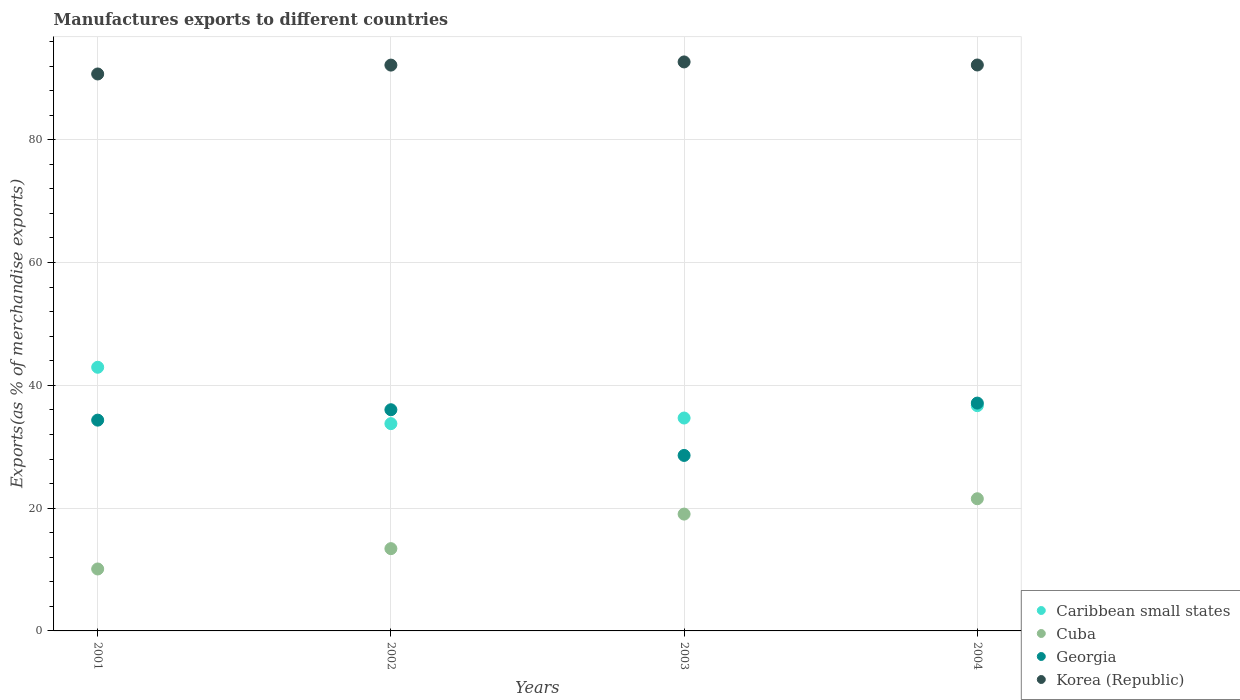How many different coloured dotlines are there?
Make the answer very short. 4. What is the percentage of exports to different countries in Korea (Republic) in 2001?
Your answer should be compact. 90.71. Across all years, what is the maximum percentage of exports to different countries in Cuba?
Your answer should be compact. 21.53. Across all years, what is the minimum percentage of exports to different countries in Korea (Republic)?
Your response must be concise. 90.71. In which year was the percentage of exports to different countries in Korea (Republic) maximum?
Give a very brief answer. 2003. What is the total percentage of exports to different countries in Caribbean small states in the graph?
Keep it short and to the point. 148.07. What is the difference between the percentage of exports to different countries in Korea (Republic) in 2001 and that in 2004?
Provide a short and direct response. -1.46. What is the difference between the percentage of exports to different countries in Cuba in 2002 and the percentage of exports to different countries in Caribbean small states in 2001?
Your answer should be compact. -29.54. What is the average percentage of exports to different countries in Korea (Republic) per year?
Keep it short and to the point. 91.93. In the year 2003, what is the difference between the percentage of exports to different countries in Georgia and percentage of exports to different countries in Cuba?
Your response must be concise. 9.56. What is the ratio of the percentage of exports to different countries in Georgia in 2003 to that in 2004?
Keep it short and to the point. 0.77. Is the percentage of exports to different countries in Korea (Republic) in 2003 less than that in 2004?
Make the answer very short. No. Is the difference between the percentage of exports to different countries in Georgia in 2002 and 2003 greater than the difference between the percentage of exports to different countries in Cuba in 2002 and 2003?
Offer a very short reply. Yes. What is the difference between the highest and the second highest percentage of exports to different countries in Caribbean small states?
Make the answer very short. 6.26. What is the difference between the highest and the lowest percentage of exports to different countries in Georgia?
Your response must be concise. 8.53. In how many years, is the percentage of exports to different countries in Georgia greater than the average percentage of exports to different countries in Georgia taken over all years?
Make the answer very short. 3. Is it the case that in every year, the sum of the percentage of exports to different countries in Georgia and percentage of exports to different countries in Cuba  is greater than the percentage of exports to different countries in Korea (Republic)?
Offer a terse response. No. What is the difference between two consecutive major ticks on the Y-axis?
Offer a terse response. 20. Are the values on the major ticks of Y-axis written in scientific E-notation?
Give a very brief answer. No. Does the graph contain any zero values?
Make the answer very short. No. What is the title of the graph?
Your response must be concise. Manufactures exports to different countries. What is the label or title of the Y-axis?
Your response must be concise. Exports(as % of merchandise exports). What is the Exports(as % of merchandise exports) of Caribbean small states in 2001?
Ensure brevity in your answer.  42.94. What is the Exports(as % of merchandise exports) of Cuba in 2001?
Keep it short and to the point. 10.09. What is the Exports(as % of merchandise exports) in Georgia in 2001?
Keep it short and to the point. 34.33. What is the Exports(as % of merchandise exports) of Korea (Republic) in 2001?
Your answer should be very brief. 90.71. What is the Exports(as % of merchandise exports) in Caribbean small states in 2002?
Offer a very short reply. 33.76. What is the Exports(as % of merchandise exports) in Cuba in 2002?
Make the answer very short. 13.4. What is the Exports(as % of merchandise exports) of Georgia in 2002?
Make the answer very short. 36.03. What is the Exports(as % of merchandise exports) of Korea (Republic) in 2002?
Offer a very short reply. 92.16. What is the Exports(as % of merchandise exports) in Caribbean small states in 2003?
Your response must be concise. 34.68. What is the Exports(as % of merchandise exports) of Cuba in 2003?
Offer a very short reply. 19.03. What is the Exports(as % of merchandise exports) of Georgia in 2003?
Offer a terse response. 28.58. What is the Exports(as % of merchandise exports) of Korea (Republic) in 2003?
Make the answer very short. 92.68. What is the Exports(as % of merchandise exports) of Caribbean small states in 2004?
Make the answer very short. 36.69. What is the Exports(as % of merchandise exports) in Cuba in 2004?
Offer a terse response. 21.53. What is the Exports(as % of merchandise exports) of Georgia in 2004?
Ensure brevity in your answer.  37.11. What is the Exports(as % of merchandise exports) in Korea (Republic) in 2004?
Provide a succinct answer. 92.18. Across all years, what is the maximum Exports(as % of merchandise exports) in Caribbean small states?
Your response must be concise. 42.94. Across all years, what is the maximum Exports(as % of merchandise exports) in Cuba?
Offer a terse response. 21.53. Across all years, what is the maximum Exports(as % of merchandise exports) in Georgia?
Make the answer very short. 37.11. Across all years, what is the maximum Exports(as % of merchandise exports) of Korea (Republic)?
Make the answer very short. 92.68. Across all years, what is the minimum Exports(as % of merchandise exports) in Caribbean small states?
Your answer should be very brief. 33.76. Across all years, what is the minimum Exports(as % of merchandise exports) in Cuba?
Make the answer very short. 10.09. Across all years, what is the minimum Exports(as % of merchandise exports) of Georgia?
Ensure brevity in your answer.  28.58. Across all years, what is the minimum Exports(as % of merchandise exports) in Korea (Republic)?
Your answer should be very brief. 90.71. What is the total Exports(as % of merchandise exports) of Caribbean small states in the graph?
Ensure brevity in your answer.  148.07. What is the total Exports(as % of merchandise exports) in Cuba in the graph?
Provide a succinct answer. 64.05. What is the total Exports(as % of merchandise exports) in Georgia in the graph?
Give a very brief answer. 136.05. What is the total Exports(as % of merchandise exports) in Korea (Republic) in the graph?
Your answer should be compact. 367.73. What is the difference between the Exports(as % of merchandise exports) of Caribbean small states in 2001 and that in 2002?
Your answer should be compact. 9.18. What is the difference between the Exports(as % of merchandise exports) of Cuba in 2001 and that in 2002?
Keep it short and to the point. -3.31. What is the difference between the Exports(as % of merchandise exports) of Georgia in 2001 and that in 2002?
Provide a short and direct response. -1.69. What is the difference between the Exports(as % of merchandise exports) in Korea (Republic) in 2001 and that in 2002?
Your response must be concise. -1.45. What is the difference between the Exports(as % of merchandise exports) in Caribbean small states in 2001 and that in 2003?
Your answer should be compact. 8.27. What is the difference between the Exports(as % of merchandise exports) of Cuba in 2001 and that in 2003?
Offer a terse response. -8.94. What is the difference between the Exports(as % of merchandise exports) in Georgia in 2001 and that in 2003?
Keep it short and to the point. 5.75. What is the difference between the Exports(as % of merchandise exports) of Korea (Republic) in 2001 and that in 2003?
Provide a short and direct response. -1.96. What is the difference between the Exports(as % of merchandise exports) in Caribbean small states in 2001 and that in 2004?
Make the answer very short. 6.26. What is the difference between the Exports(as % of merchandise exports) of Cuba in 2001 and that in 2004?
Your answer should be very brief. -11.44. What is the difference between the Exports(as % of merchandise exports) of Georgia in 2001 and that in 2004?
Ensure brevity in your answer.  -2.78. What is the difference between the Exports(as % of merchandise exports) in Korea (Republic) in 2001 and that in 2004?
Keep it short and to the point. -1.46. What is the difference between the Exports(as % of merchandise exports) of Caribbean small states in 2002 and that in 2003?
Your response must be concise. -0.92. What is the difference between the Exports(as % of merchandise exports) in Cuba in 2002 and that in 2003?
Your answer should be very brief. -5.63. What is the difference between the Exports(as % of merchandise exports) of Georgia in 2002 and that in 2003?
Give a very brief answer. 7.44. What is the difference between the Exports(as % of merchandise exports) of Korea (Republic) in 2002 and that in 2003?
Your answer should be very brief. -0.52. What is the difference between the Exports(as % of merchandise exports) of Caribbean small states in 2002 and that in 2004?
Offer a very short reply. -2.93. What is the difference between the Exports(as % of merchandise exports) of Cuba in 2002 and that in 2004?
Your answer should be very brief. -8.13. What is the difference between the Exports(as % of merchandise exports) of Georgia in 2002 and that in 2004?
Offer a terse response. -1.08. What is the difference between the Exports(as % of merchandise exports) in Korea (Republic) in 2002 and that in 2004?
Offer a terse response. -0.02. What is the difference between the Exports(as % of merchandise exports) of Caribbean small states in 2003 and that in 2004?
Your answer should be very brief. -2.01. What is the difference between the Exports(as % of merchandise exports) of Cuba in 2003 and that in 2004?
Your response must be concise. -2.5. What is the difference between the Exports(as % of merchandise exports) of Georgia in 2003 and that in 2004?
Your response must be concise. -8.53. What is the difference between the Exports(as % of merchandise exports) in Korea (Republic) in 2003 and that in 2004?
Provide a short and direct response. 0.5. What is the difference between the Exports(as % of merchandise exports) of Caribbean small states in 2001 and the Exports(as % of merchandise exports) of Cuba in 2002?
Your answer should be compact. 29.54. What is the difference between the Exports(as % of merchandise exports) in Caribbean small states in 2001 and the Exports(as % of merchandise exports) in Georgia in 2002?
Your response must be concise. 6.92. What is the difference between the Exports(as % of merchandise exports) in Caribbean small states in 2001 and the Exports(as % of merchandise exports) in Korea (Republic) in 2002?
Provide a succinct answer. -49.22. What is the difference between the Exports(as % of merchandise exports) in Cuba in 2001 and the Exports(as % of merchandise exports) in Georgia in 2002?
Your response must be concise. -25.94. What is the difference between the Exports(as % of merchandise exports) of Cuba in 2001 and the Exports(as % of merchandise exports) of Korea (Republic) in 2002?
Your answer should be very brief. -82.07. What is the difference between the Exports(as % of merchandise exports) of Georgia in 2001 and the Exports(as % of merchandise exports) of Korea (Republic) in 2002?
Your answer should be compact. -57.83. What is the difference between the Exports(as % of merchandise exports) in Caribbean small states in 2001 and the Exports(as % of merchandise exports) in Cuba in 2003?
Provide a succinct answer. 23.92. What is the difference between the Exports(as % of merchandise exports) in Caribbean small states in 2001 and the Exports(as % of merchandise exports) in Georgia in 2003?
Your answer should be very brief. 14.36. What is the difference between the Exports(as % of merchandise exports) of Caribbean small states in 2001 and the Exports(as % of merchandise exports) of Korea (Republic) in 2003?
Keep it short and to the point. -49.73. What is the difference between the Exports(as % of merchandise exports) of Cuba in 2001 and the Exports(as % of merchandise exports) of Georgia in 2003?
Give a very brief answer. -18.49. What is the difference between the Exports(as % of merchandise exports) of Cuba in 2001 and the Exports(as % of merchandise exports) of Korea (Republic) in 2003?
Provide a short and direct response. -82.59. What is the difference between the Exports(as % of merchandise exports) of Georgia in 2001 and the Exports(as % of merchandise exports) of Korea (Republic) in 2003?
Offer a very short reply. -58.34. What is the difference between the Exports(as % of merchandise exports) of Caribbean small states in 2001 and the Exports(as % of merchandise exports) of Cuba in 2004?
Offer a terse response. 21.42. What is the difference between the Exports(as % of merchandise exports) of Caribbean small states in 2001 and the Exports(as % of merchandise exports) of Georgia in 2004?
Offer a very short reply. 5.83. What is the difference between the Exports(as % of merchandise exports) in Caribbean small states in 2001 and the Exports(as % of merchandise exports) in Korea (Republic) in 2004?
Your response must be concise. -49.23. What is the difference between the Exports(as % of merchandise exports) in Cuba in 2001 and the Exports(as % of merchandise exports) in Georgia in 2004?
Ensure brevity in your answer.  -27.02. What is the difference between the Exports(as % of merchandise exports) of Cuba in 2001 and the Exports(as % of merchandise exports) of Korea (Republic) in 2004?
Provide a short and direct response. -82.09. What is the difference between the Exports(as % of merchandise exports) of Georgia in 2001 and the Exports(as % of merchandise exports) of Korea (Republic) in 2004?
Ensure brevity in your answer.  -57.85. What is the difference between the Exports(as % of merchandise exports) in Caribbean small states in 2002 and the Exports(as % of merchandise exports) in Cuba in 2003?
Your answer should be very brief. 14.73. What is the difference between the Exports(as % of merchandise exports) in Caribbean small states in 2002 and the Exports(as % of merchandise exports) in Georgia in 2003?
Ensure brevity in your answer.  5.18. What is the difference between the Exports(as % of merchandise exports) in Caribbean small states in 2002 and the Exports(as % of merchandise exports) in Korea (Republic) in 2003?
Your answer should be very brief. -58.92. What is the difference between the Exports(as % of merchandise exports) in Cuba in 2002 and the Exports(as % of merchandise exports) in Georgia in 2003?
Your answer should be compact. -15.18. What is the difference between the Exports(as % of merchandise exports) of Cuba in 2002 and the Exports(as % of merchandise exports) of Korea (Republic) in 2003?
Offer a terse response. -79.28. What is the difference between the Exports(as % of merchandise exports) in Georgia in 2002 and the Exports(as % of merchandise exports) in Korea (Republic) in 2003?
Offer a very short reply. -56.65. What is the difference between the Exports(as % of merchandise exports) of Caribbean small states in 2002 and the Exports(as % of merchandise exports) of Cuba in 2004?
Provide a short and direct response. 12.23. What is the difference between the Exports(as % of merchandise exports) of Caribbean small states in 2002 and the Exports(as % of merchandise exports) of Georgia in 2004?
Offer a very short reply. -3.35. What is the difference between the Exports(as % of merchandise exports) in Caribbean small states in 2002 and the Exports(as % of merchandise exports) in Korea (Republic) in 2004?
Offer a very short reply. -58.42. What is the difference between the Exports(as % of merchandise exports) in Cuba in 2002 and the Exports(as % of merchandise exports) in Georgia in 2004?
Give a very brief answer. -23.71. What is the difference between the Exports(as % of merchandise exports) of Cuba in 2002 and the Exports(as % of merchandise exports) of Korea (Republic) in 2004?
Your response must be concise. -78.78. What is the difference between the Exports(as % of merchandise exports) in Georgia in 2002 and the Exports(as % of merchandise exports) in Korea (Republic) in 2004?
Your answer should be compact. -56.15. What is the difference between the Exports(as % of merchandise exports) of Caribbean small states in 2003 and the Exports(as % of merchandise exports) of Cuba in 2004?
Offer a terse response. 13.15. What is the difference between the Exports(as % of merchandise exports) of Caribbean small states in 2003 and the Exports(as % of merchandise exports) of Georgia in 2004?
Keep it short and to the point. -2.43. What is the difference between the Exports(as % of merchandise exports) in Caribbean small states in 2003 and the Exports(as % of merchandise exports) in Korea (Republic) in 2004?
Give a very brief answer. -57.5. What is the difference between the Exports(as % of merchandise exports) of Cuba in 2003 and the Exports(as % of merchandise exports) of Georgia in 2004?
Ensure brevity in your answer.  -18.08. What is the difference between the Exports(as % of merchandise exports) of Cuba in 2003 and the Exports(as % of merchandise exports) of Korea (Republic) in 2004?
Your answer should be very brief. -73.15. What is the difference between the Exports(as % of merchandise exports) in Georgia in 2003 and the Exports(as % of merchandise exports) in Korea (Republic) in 2004?
Offer a very short reply. -63.59. What is the average Exports(as % of merchandise exports) in Caribbean small states per year?
Your response must be concise. 37.02. What is the average Exports(as % of merchandise exports) of Cuba per year?
Your answer should be compact. 16.01. What is the average Exports(as % of merchandise exports) of Georgia per year?
Your answer should be very brief. 34.01. What is the average Exports(as % of merchandise exports) in Korea (Republic) per year?
Make the answer very short. 91.93. In the year 2001, what is the difference between the Exports(as % of merchandise exports) of Caribbean small states and Exports(as % of merchandise exports) of Cuba?
Your answer should be compact. 32.85. In the year 2001, what is the difference between the Exports(as % of merchandise exports) in Caribbean small states and Exports(as % of merchandise exports) in Georgia?
Provide a succinct answer. 8.61. In the year 2001, what is the difference between the Exports(as % of merchandise exports) in Caribbean small states and Exports(as % of merchandise exports) in Korea (Republic)?
Offer a terse response. -47.77. In the year 2001, what is the difference between the Exports(as % of merchandise exports) in Cuba and Exports(as % of merchandise exports) in Georgia?
Give a very brief answer. -24.24. In the year 2001, what is the difference between the Exports(as % of merchandise exports) of Cuba and Exports(as % of merchandise exports) of Korea (Republic)?
Ensure brevity in your answer.  -80.62. In the year 2001, what is the difference between the Exports(as % of merchandise exports) in Georgia and Exports(as % of merchandise exports) in Korea (Republic)?
Make the answer very short. -56.38. In the year 2002, what is the difference between the Exports(as % of merchandise exports) in Caribbean small states and Exports(as % of merchandise exports) in Cuba?
Ensure brevity in your answer.  20.36. In the year 2002, what is the difference between the Exports(as % of merchandise exports) of Caribbean small states and Exports(as % of merchandise exports) of Georgia?
Your response must be concise. -2.26. In the year 2002, what is the difference between the Exports(as % of merchandise exports) in Caribbean small states and Exports(as % of merchandise exports) in Korea (Republic)?
Provide a short and direct response. -58.4. In the year 2002, what is the difference between the Exports(as % of merchandise exports) in Cuba and Exports(as % of merchandise exports) in Georgia?
Keep it short and to the point. -22.62. In the year 2002, what is the difference between the Exports(as % of merchandise exports) in Cuba and Exports(as % of merchandise exports) in Korea (Republic)?
Offer a very short reply. -78.76. In the year 2002, what is the difference between the Exports(as % of merchandise exports) in Georgia and Exports(as % of merchandise exports) in Korea (Republic)?
Your response must be concise. -56.13. In the year 2003, what is the difference between the Exports(as % of merchandise exports) in Caribbean small states and Exports(as % of merchandise exports) in Cuba?
Offer a terse response. 15.65. In the year 2003, what is the difference between the Exports(as % of merchandise exports) of Caribbean small states and Exports(as % of merchandise exports) of Georgia?
Your answer should be very brief. 6.09. In the year 2003, what is the difference between the Exports(as % of merchandise exports) of Caribbean small states and Exports(as % of merchandise exports) of Korea (Republic)?
Provide a succinct answer. -58. In the year 2003, what is the difference between the Exports(as % of merchandise exports) in Cuba and Exports(as % of merchandise exports) in Georgia?
Provide a short and direct response. -9.56. In the year 2003, what is the difference between the Exports(as % of merchandise exports) in Cuba and Exports(as % of merchandise exports) in Korea (Republic)?
Offer a terse response. -73.65. In the year 2003, what is the difference between the Exports(as % of merchandise exports) in Georgia and Exports(as % of merchandise exports) in Korea (Republic)?
Make the answer very short. -64.09. In the year 2004, what is the difference between the Exports(as % of merchandise exports) in Caribbean small states and Exports(as % of merchandise exports) in Cuba?
Keep it short and to the point. 15.16. In the year 2004, what is the difference between the Exports(as % of merchandise exports) in Caribbean small states and Exports(as % of merchandise exports) in Georgia?
Offer a very short reply. -0.42. In the year 2004, what is the difference between the Exports(as % of merchandise exports) in Caribbean small states and Exports(as % of merchandise exports) in Korea (Republic)?
Your answer should be very brief. -55.49. In the year 2004, what is the difference between the Exports(as % of merchandise exports) in Cuba and Exports(as % of merchandise exports) in Georgia?
Provide a short and direct response. -15.58. In the year 2004, what is the difference between the Exports(as % of merchandise exports) in Cuba and Exports(as % of merchandise exports) in Korea (Republic)?
Offer a very short reply. -70.65. In the year 2004, what is the difference between the Exports(as % of merchandise exports) in Georgia and Exports(as % of merchandise exports) in Korea (Republic)?
Your answer should be compact. -55.07. What is the ratio of the Exports(as % of merchandise exports) in Caribbean small states in 2001 to that in 2002?
Make the answer very short. 1.27. What is the ratio of the Exports(as % of merchandise exports) in Cuba in 2001 to that in 2002?
Ensure brevity in your answer.  0.75. What is the ratio of the Exports(as % of merchandise exports) in Georgia in 2001 to that in 2002?
Your answer should be very brief. 0.95. What is the ratio of the Exports(as % of merchandise exports) in Korea (Republic) in 2001 to that in 2002?
Keep it short and to the point. 0.98. What is the ratio of the Exports(as % of merchandise exports) in Caribbean small states in 2001 to that in 2003?
Ensure brevity in your answer.  1.24. What is the ratio of the Exports(as % of merchandise exports) in Cuba in 2001 to that in 2003?
Provide a short and direct response. 0.53. What is the ratio of the Exports(as % of merchandise exports) in Georgia in 2001 to that in 2003?
Offer a very short reply. 1.2. What is the ratio of the Exports(as % of merchandise exports) in Korea (Republic) in 2001 to that in 2003?
Provide a short and direct response. 0.98. What is the ratio of the Exports(as % of merchandise exports) in Caribbean small states in 2001 to that in 2004?
Provide a short and direct response. 1.17. What is the ratio of the Exports(as % of merchandise exports) in Cuba in 2001 to that in 2004?
Keep it short and to the point. 0.47. What is the ratio of the Exports(as % of merchandise exports) of Georgia in 2001 to that in 2004?
Your answer should be very brief. 0.93. What is the ratio of the Exports(as % of merchandise exports) of Korea (Republic) in 2001 to that in 2004?
Give a very brief answer. 0.98. What is the ratio of the Exports(as % of merchandise exports) in Caribbean small states in 2002 to that in 2003?
Provide a short and direct response. 0.97. What is the ratio of the Exports(as % of merchandise exports) in Cuba in 2002 to that in 2003?
Offer a terse response. 0.7. What is the ratio of the Exports(as % of merchandise exports) of Georgia in 2002 to that in 2003?
Make the answer very short. 1.26. What is the ratio of the Exports(as % of merchandise exports) of Caribbean small states in 2002 to that in 2004?
Provide a short and direct response. 0.92. What is the ratio of the Exports(as % of merchandise exports) in Cuba in 2002 to that in 2004?
Offer a terse response. 0.62. What is the ratio of the Exports(as % of merchandise exports) in Georgia in 2002 to that in 2004?
Your answer should be compact. 0.97. What is the ratio of the Exports(as % of merchandise exports) of Caribbean small states in 2003 to that in 2004?
Offer a terse response. 0.95. What is the ratio of the Exports(as % of merchandise exports) in Cuba in 2003 to that in 2004?
Ensure brevity in your answer.  0.88. What is the ratio of the Exports(as % of merchandise exports) of Georgia in 2003 to that in 2004?
Ensure brevity in your answer.  0.77. What is the ratio of the Exports(as % of merchandise exports) in Korea (Republic) in 2003 to that in 2004?
Your response must be concise. 1.01. What is the difference between the highest and the second highest Exports(as % of merchandise exports) in Caribbean small states?
Provide a succinct answer. 6.26. What is the difference between the highest and the second highest Exports(as % of merchandise exports) of Cuba?
Your answer should be very brief. 2.5. What is the difference between the highest and the second highest Exports(as % of merchandise exports) in Georgia?
Offer a terse response. 1.08. What is the difference between the highest and the second highest Exports(as % of merchandise exports) of Korea (Republic)?
Provide a short and direct response. 0.5. What is the difference between the highest and the lowest Exports(as % of merchandise exports) of Caribbean small states?
Your answer should be very brief. 9.18. What is the difference between the highest and the lowest Exports(as % of merchandise exports) of Cuba?
Offer a terse response. 11.44. What is the difference between the highest and the lowest Exports(as % of merchandise exports) in Georgia?
Ensure brevity in your answer.  8.53. What is the difference between the highest and the lowest Exports(as % of merchandise exports) in Korea (Republic)?
Give a very brief answer. 1.96. 